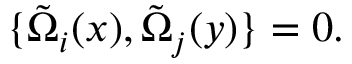<formula> <loc_0><loc_0><loc_500><loc_500>\{ \tilde { \Omega } _ { i } ( x ) , \tilde { \Omega } _ { j } ( y ) \} = 0 .</formula> 